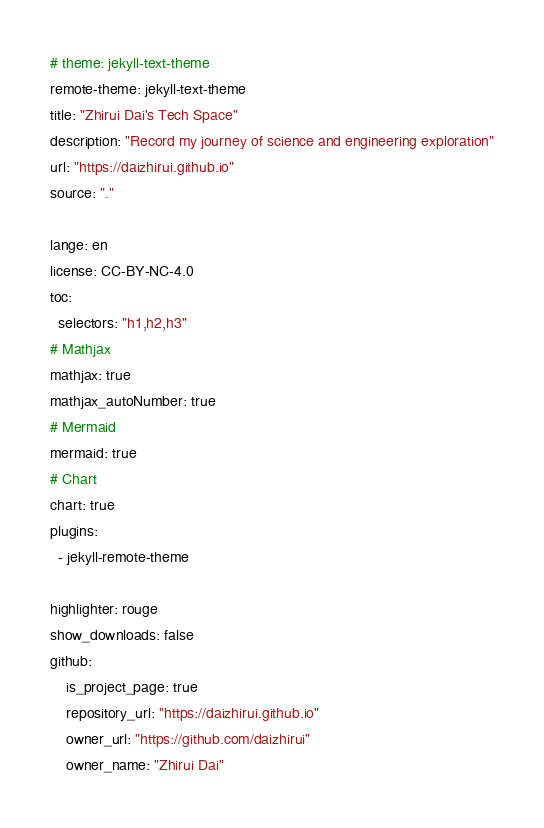Convert code to text. <code><loc_0><loc_0><loc_500><loc_500><_YAML_># theme: jekyll-text-theme
remote-theme: jekyll-text-theme
title: "Zhirui Dai's Tech Space"
description: "Record my journey of science and engineering exploration"
url: "https://daizhirui.github.io"
source: "."

lange: en
license: CC-BY-NC-4.0
toc:
  selectors: "h1,h2,h3"
# Mathjax
mathjax: true
mathjax_autoNumber: true
# Mermaid
mermaid: true
# Chart
chart: true
plugins:
  - jekyll-remote-theme

highlighter: rouge
show_downloads: false
github:
    is_project_page: true
    repository_url: "https://daizhirui.github.io"
    owner_url: "https://github.com/daizhirui"
    owner_name: "Zhirui Dai"
</code> 